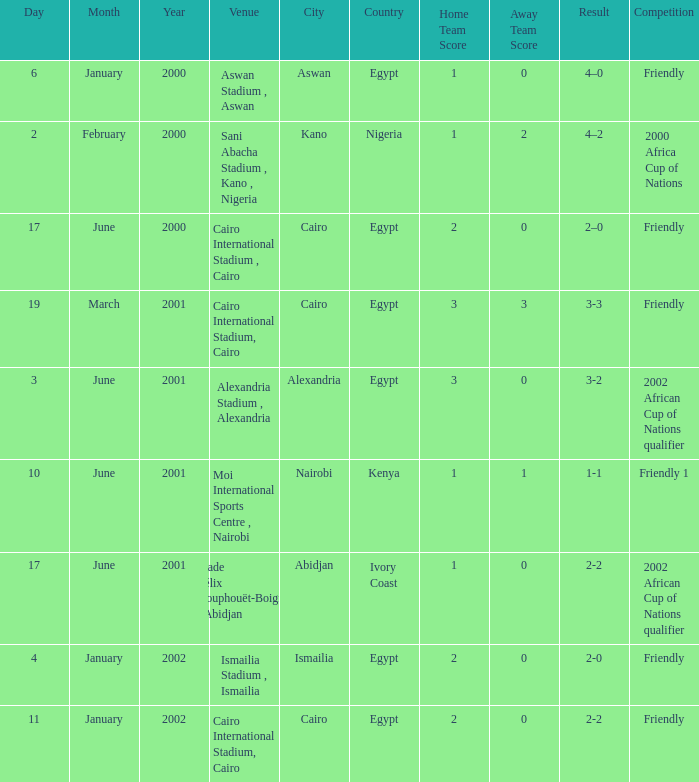What is the score of the match with a 3-2 result? 3–0. 